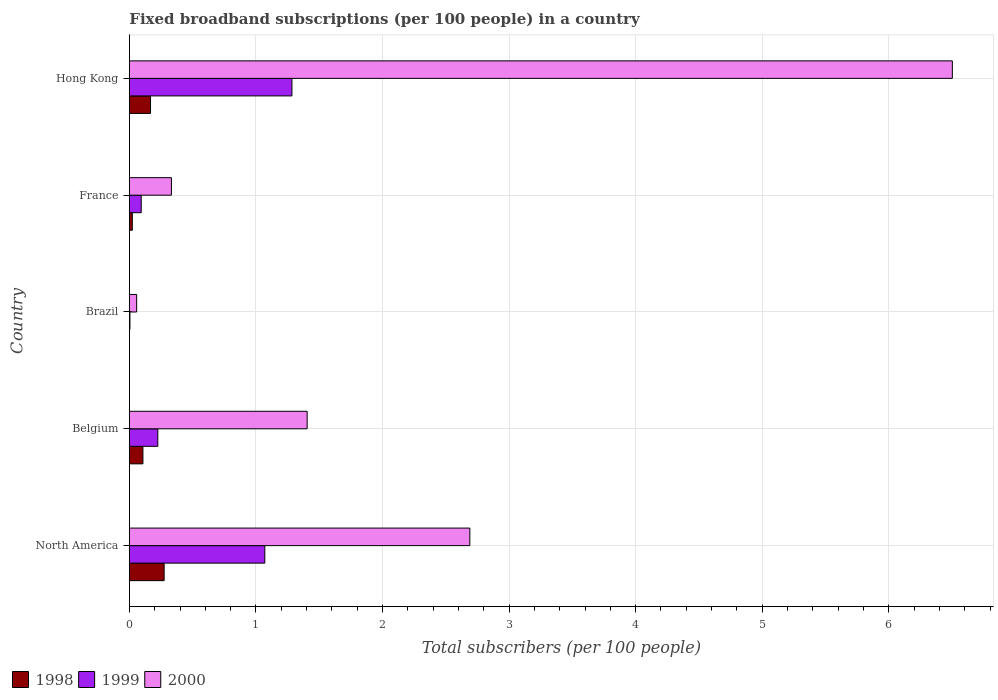How many groups of bars are there?
Offer a very short reply. 5. Are the number of bars on each tick of the Y-axis equal?
Keep it short and to the point. Yes. How many bars are there on the 4th tick from the top?
Ensure brevity in your answer.  3. What is the label of the 3rd group of bars from the top?
Ensure brevity in your answer.  Brazil. What is the number of broadband subscriptions in 1999 in Hong Kong?
Provide a succinct answer. 1.28. Across all countries, what is the maximum number of broadband subscriptions in 1998?
Ensure brevity in your answer.  0.27. Across all countries, what is the minimum number of broadband subscriptions in 1999?
Provide a succinct answer. 0. In which country was the number of broadband subscriptions in 1999 maximum?
Give a very brief answer. Hong Kong. In which country was the number of broadband subscriptions in 1998 minimum?
Ensure brevity in your answer.  Brazil. What is the total number of broadband subscriptions in 1998 in the graph?
Offer a terse response. 0.57. What is the difference between the number of broadband subscriptions in 1998 in Belgium and that in Hong Kong?
Your answer should be compact. -0.06. What is the difference between the number of broadband subscriptions in 1998 in Hong Kong and the number of broadband subscriptions in 2000 in France?
Make the answer very short. -0.17. What is the average number of broadband subscriptions in 2000 per country?
Your answer should be very brief. 2.2. What is the difference between the number of broadband subscriptions in 1999 and number of broadband subscriptions in 2000 in North America?
Give a very brief answer. -1.62. What is the ratio of the number of broadband subscriptions in 1999 in Brazil to that in North America?
Provide a succinct answer. 0. Is the number of broadband subscriptions in 1999 in Hong Kong less than that in North America?
Keep it short and to the point. No. What is the difference between the highest and the second highest number of broadband subscriptions in 1999?
Keep it short and to the point. 0.21. What is the difference between the highest and the lowest number of broadband subscriptions in 1999?
Offer a very short reply. 1.28. Is it the case that in every country, the sum of the number of broadband subscriptions in 2000 and number of broadband subscriptions in 1998 is greater than the number of broadband subscriptions in 1999?
Give a very brief answer. Yes. How many bars are there?
Your answer should be compact. 15. What is the difference between two consecutive major ticks on the X-axis?
Offer a very short reply. 1. Are the values on the major ticks of X-axis written in scientific E-notation?
Provide a short and direct response. No. Does the graph contain any zero values?
Offer a terse response. No. Does the graph contain grids?
Keep it short and to the point. Yes. Where does the legend appear in the graph?
Make the answer very short. Bottom left. How many legend labels are there?
Provide a short and direct response. 3. How are the legend labels stacked?
Give a very brief answer. Horizontal. What is the title of the graph?
Your response must be concise. Fixed broadband subscriptions (per 100 people) in a country. What is the label or title of the X-axis?
Provide a short and direct response. Total subscribers (per 100 people). What is the Total subscribers (per 100 people) in 1998 in North America?
Ensure brevity in your answer.  0.27. What is the Total subscribers (per 100 people) in 1999 in North America?
Make the answer very short. 1.07. What is the Total subscribers (per 100 people) in 2000 in North America?
Keep it short and to the point. 2.69. What is the Total subscribers (per 100 people) in 1998 in Belgium?
Offer a terse response. 0.11. What is the Total subscribers (per 100 people) in 1999 in Belgium?
Make the answer very short. 0.22. What is the Total subscribers (per 100 people) of 2000 in Belgium?
Provide a short and direct response. 1.4. What is the Total subscribers (per 100 people) in 1998 in Brazil?
Ensure brevity in your answer.  0. What is the Total subscribers (per 100 people) of 1999 in Brazil?
Your response must be concise. 0. What is the Total subscribers (per 100 people) of 2000 in Brazil?
Make the answer very short. 0.06. What is the Total subscribers (per 100 people) of 1998 in France?
Make the answer very short. 0.02. What is the Total subscribers (per 100 people) of 1999 in France?
Provide a succinct answer. 0.09. What is the Total subscribers (per 100 people) in 2000 in France?
Provide a short and direct response. 0.33. What is the Total subscribers (per 100 people) of 1998 in Hong Kong?
Make the answer very short. 0.17. What is the Total subscribers (per 100 people) of 1999 in Hong Kong?
Provide a succinct answer. 1.28. What is the Total subscribers (per 100 people) of 2000 in Hong Kong?
Your answer should be very brief. 6.5. Across all countries, what is the maximum Total subscribers (per 100 people) of 1998?
Offer a very short reply. 0.27. Across all countries, what is the maximum Total subscribers (per 100 people) of 1999?
Provide a succinct answer. 1.28. Across all countries, what is the maximum Total subscribers (per 100 people) in 2000?
Provide a succinct answer. 6.5. Across all countries, what is the minimum Total subscribers (per 100 people) of 1998?
Make the answer very short. 0. Across all countries, what is the minimum Total subscribers (per 100 people) in 1999?
Offer a very short reply. 0. Across all countries, what is the minimum Total subscribers (per 100 people) of 2000?
Your answer should be very brief. 0.06. What is the total Total subscribers (per 100 people) of 1998 in the graph?
Provide a short and direct response. 0.57. What is the total Total subscribers (per 100 people) of 1999 in the graph?
Your response must be concise. 2.68. What is the total Total subscribers (per 100 people) of 2000 in the graph?
Your answer should be compact. 10.99. What is the difference between the Total subscribers (per 100 people) in 1998 in North America and that in Belgium?
Make the answer very short. 0.17. What is the difference between the Total subscribers (per 100 people) of 1999 in North America and that in Belgium?
Your answer should be very brief. 0.85. What is the difference between the Total subscribers (per 100 people) of 2000 in North America and that in Belgium?
Make the answer very short. 1.29. What is the difference between the Total subscribers (per 100 people) in 1998 in North America and that in Brazil?
Your response must be concise. 0.27. What is the difference between the Total subscribers (per 100 people) of 1999 in North America and that in Brazil?
Offer a very short reply. 1.07. What is the difference between the Total subscribers (per 100 people) of 2000 in North America and that in Brazil?
Your answer should be very brief. 2.63. What is the difference between the Total subscribers (per 100 people) of 1998 in North America and that in France?
Your response must be concise. 0.25. What is the difference between the Total subscribers (per 100 people) in 1999 in North America and that in France?
Your answer should be compact. 0.98. What is the difference between the Total subscribers (per 100 people) in 2000 in North America and that in France?
Your response must be concise. 2.36. What is the difference between the Total subscribers (per 100 people) of 1998 in North America and that in Hong Kong?
Provide a succinct answer. 0.11. What is the difference between the Total subscribers (per 100 people) of 1999 in North America and that in Hong Kong?
Ensure brevity in your answer.  -0.21. What is the difference between the Total subscribers (per 100 people) of 2000 in North America and that in Hong Kong?
Offer a terse response. -3.81. What is the difference between the Total subscribers (per 100 people) of 1998 in Belgium and that in Brazil?
Give a very brief answer. 0.11. What is the difference between the Total subscribers (per 100 people) in 1999 in Belgium and that in Brazil?
Your answer should be very brief. 0.22. What is the difference between the Total subscribers (per 100 people) in 2000 in Belgium and that in Brazil?
Provide a short and direct response. 1.35. What is the difference between the Total subscribers (per 100 people) of 1998 in Belgium and that in France?
Offer a very short reply. 0.08. What is the difference between the Total subscribers (per 100 people) in 1999 in Belgium and that in France?
Make the answer very short. 0.13. What is the difference between the Total subscribers (per 100 people) in 2000 in Belgium and that in France?
Give a very brief answer. 1.07. What is the difference between the Total subscribers (per 100 people) in 1998 in Belgium and that in Hong Kong?
Offer a terse response. -0.06. What is the difference between the Total subscribers (per 100 people) in 1999 in Belgium and that in Hong Kong?
Make the answer very short. -1.06. What is the difference between the Total subscribers (per 100 people) of 2000 in Belgium and that in Hong Kong?
Your answer should be very brief. -5.1. What is the difference between the Total subscribers (per 100 people) in 1998 in Brazil and that in France?
Make the answer very short. -0.02. What is the difference between the Total subscribers (per 100 people) in 1999 in Brazil and that in France?
Provide a succinct answer. -0.09. What is the difference between the Total subscribers (per 100 people) in 2000 in Brazil and that in France?
Offer a very short reply. -0.27. What is the difference between the Total subscribers (per 100 people) of 1998 in Brazil and that in Hong Kong?
Make the answer very short. -0.17. What is the difference between the Total subscribers (per 100 people) in 1999 in Brazil and that in Hong Kong?
Provide a short and direct response. -1.28. What is the difference between the Total subscribers (per 100 people) in 2000 in Brazil and that in Hong Kong?
Offer a very short reply. -6.45. What is the difference between the Total subscribers (per 100 people) in 1998 in France and that in Hong Kong?
Your answer should be very brief. -0.14. What is the difference between the Total subscribers (per 100 people) in 1999 in France and that in Hong Kong?
Ensure brevity in your answer.  -1.19. What is the difference between the Total subscribers (per 100 people) of 2000 in France and that in Hong Kong?
Provide a succinct answer. -6.17. What is the difference between the Total subscribers (per 100 people) of 1998 in North America and the Total subscribers (per 100 people) of 1999 in Belgium?
Offer a very short reply. 0.05. What is the difference between the Total subscribers (per 100 people) in 1998 in North America and the Total subscribers (per 100 people) in 2000 in Belgium?
Keep it short and to the point. -1.13. What is the difference between the Total subscribers (per 100 people) in 1999 in North America and the Total subscribers (per 100 people) in 2000 in Belgium?
Your answer should be very brief. -0.33. What is the difference between the Total subscribers (per 100 people) of 1998 in North America and the Total subscribers (per 100 people) of 1999 in Brazil?
Ensure brevity in your answer.  0.27. What is the difference between the Total subscribers (per 100 people) in 1998 in North America and the Total subscribers (per 100 people) in 2000 in Brazil?
Keep it short and to the point. 0.22. What is the difference between the Total subscribers (per 100 people) in 1999 in North America and the Total subscribers (per 100 people) in 2000 in Brazil?
Your answer should be compact. 1.01. What is the difference between the Total subscribers (per 100 people) of 1998 in North America and the Total subscribers (per 100 people) of 1999 in France?
Provide a succinct answer. 0.18. What is the difference between the Total subscribers (per 100 people) in 1998 in North America and the Total subscribers (per 100 people) in 2000 in France?
Keep it short and to the point. -0.06. What is the difference between the Total subscribers (per 100 people) of 1999 in North America and the Total subscribers (per 100 people) of 2000 in France?
Ensure brevity in your answer.  0.74. What is the difference between the Total subscribers (per 100 people) in 1998 in North America and the Total subscribers (per 100 people) in 1999 in Hong Kong?
Make the answer very short. -1.01. What is the difference between the Total subscribers (per 100 people) of 1998 in North America and the Total subscribers (per 100 people) of 2000 in Hong Kong?
Your answer should be very brief. -6.23. What is the difference between the Total subscribers (per 100 people) in 1999 in North America and the Total subscribers (per 100 people) in 2000 in Hong Kong?
Keep it short and to the point. -5.43. What is the difference between the Total subscribers (per 100 people) in 1998 in Belgium and the Total subscribers (per 100 people) in 1999 in Brazil?
Keep it short and to the point. 0.1. What is the difference between the Total subscribers (per 100 people) of 1998 in Belgium and the Total subscribers (per 100 people) of 2000 in Brazil?
Make the answer very short. 0.05. What is the difference between the Total subscribers (per 100 people) in 1999 in Belgium and the Total subscribers (per 100 people) in 2000 in Brazil?
Keep it short and to the point. 0.17. What is the difference between the Total subscribers (per 100 people) in 1998 in Belgium and the Total subscribers (per 100 people) in 1999 in France?
Offer a terse response. 0.01. What is the difference between the Total subscribers (per 100 people) in 1998 in Belgium and the Total subscribers (per 100 people) in 2000 in France?
Offer a terse response. -0.23. What is the difference between the Total subscribers (per 100 people) in 1999 in Belgium and the Total subscribers (per 100 people) in 2000 in France?
Keep it short and to the point. -0.11. What is the difference between the Total subscribers (per 100 people) of 1998 in Belgium and the Total subscribers (per 100 people) of 1999 in Hong Kong?
Keep it short and to the point. -1.18. What is the difference between the Total subscribers (per 100 people) of 1998 in Belgium and the Total subscribers (per 100 people) of 2000 in Hong Kong?
Your response must be concise. -6.4. What is the difference between the Total subscribers (per 100 people) of 1999 in Belgium and the Total subscribers (per 100 people) of 2000 in Hong Kong?
Offer a very short reply. -6.28. What is the difference between the Total subscribers (per 100 people) in 1998 in Brazil and the Total subscribers (per 100 people) in 1999 in France?
Offer a very short reply. -0.09. What is the difference between the Total subscribers (per 100 people) in 1998 in Brazil and the Total subscribers (per 100 people) in 2000 in France?
Give a very brief answer. -0.33. What is the difference between the Total subscribers (per 100 people) of 1999 in Brazil and the Total subscribers (per 100 people) of 2000 in France?
Make the answer very short. -0.33. What is the difference between the Total subscribers (per 100 people) in 1998 in Brazil and the Total subscribers (per 100 people) in 1999 in Hong Kong?
Offer a very short reply. -1.28. What is the difference between the Total subscribers (per 100 people) in 1998 in Brazil and the Total subscribers (per 100 people) in 2000 in Hong Kong?
Provide a succinct answer. -6.5. What is the difference between the Total subscribers (per 100 people) in 1999 in Brazil and the Total subscribers (per 100 people) in 2000 in Hong Kong?
Your answer should be compact. -6.5. What is the difference between the Total subscribers (per 100 people) of 1998 in France and the Total subscribers (per 100 people) of 1999 in Hong Kong?
Ensure brevity in your answer.  -1.26. What is the difference between the Total subscribers (per 100 people) of 1998 in France and the Total subscribers (per 100 people) of 2000 in Hong Kong?
Keep it short and to the point. -6.48. What is the difference between the Total subscribers (per 100 people) of 1999 in France and the Total subscribers (per 100 people) of 2000 in Hong Kong?
Offer a terse response. -6.41. What is the average Total subscribers (per 100 people) of 1998 per country?
Your answer should be very brief. 0.11. What is the average Total subscribers (per 100 people) in 1999 per country?
Ensure brevity in your answer.  0.54. What is the average Total subscribers (per 100 people) in 2000 per country?
Your answer should be compact. 2.2. What is the difference between the Total subscribers (per 100 people) of 1998 and Total subscribers (per 100 people) of 1999 in North America?
Offer a terse response. -0.8. What is the difference between the Total subscribers (per 100 people) in 1998 and Total subscribers (per 100 people) in 2000 in North America?
Your answer should be very brief. -2.42. What is the difference between the Total subscribers (per 100 people) of 1999 and Total subscribers (per 100 people) of 2000 in North America?
Provide a succinct answer. -1.62. What is the difference between the Total subscribers (per 100 people) of 1998 and Total subscribers (per 100 people) of 1999 in Belgium?
Make the answer very short. -0.12. What is the difference between the Total subscribers (per 100 people) of 1998 and Total subscribers (per 100 people) of 2000 in Belgium?
Provide a short and direct response. -1.3. What is the difference between the Total subscribers (per 100 people) of 1999 and Total subscribers (per 100 people) of 2000 in Belgium?
Your answer should be compact. -1.18. What is the difference between the Total subscribers (per 100 people) of 1998 and Total subscribers (per 100 people) of 1999 in Brazil?
Offer a very short reply. -0. What is the difference between the Total subscribers (per 100 people) of 1998 and Total subscribers (per 100 people) of 2000 in Brazil?
Your answer should be compact. -0.06. What is the difference between the Total subscribers (per 100 people) of 1999 and Total subscribers (per 100 people) of 2000 in Brazil?
Keep it short and to the point. -0.05. What is the difference between the Total subscribers (per 100 people) in 1998 and Total subscribers (per 100 people) in 1999 in France?
Provide a succinct answer. -0.07. What is the difference between the Total subscribers (per 100 people) of 1998 and Total subscribers (per 100 people) of 2000 in France?
Ensure brevity in your answer.  -0.31. What is the difference between the Total subscribers (per 100 people) in 1999 and Total subscribers (per 100 people) in 2000 in France?
Offer a terse response. -0.24. What is the difference between the Total subscribers (per 100 people) of 1998 and Total subscribers (per 100 people) of 1999 in Hong Kong?
Ensure brevity in your answer.  -1.12. What is the difference between the Total subscribers (per 100 people) in 1998 and Total subscribers (per 100 people) in 2000 in Hong Kong?
Make the answer very short. -6.34. What is the difference between the Total subscribers (per 100 people) of 1999 and Total subscribers (per 100 people) of 2000 in Hong Kong?
Keep it short and to the point. -5.22. What is the ratio of the Total subscribers (per 100 people) in 1998 in North America to that in Belgium?
Your answer should be very brief. 2.57. What is the ratio of the Total subscribers (per 100 people) of 1999 in North America to that in Belgium?
Offer a very short reply. 4.76. What is the ratio of the Total subscribers (per 100 people) in 2000 in North America to that in Belgium?
Make the answer very short. 1.92. What is the ratio of the Total subscribers (per 100 people) of 1998 in North America to that in Brazil?
Offer a terse response. 465.15. What is the ratio of the Total subscribers (per 100 people) in 1999 in North America to that in Brazil?
Offer a very short reply. 262.9. What is the ratio of the Total subscribers (per 100 people) of 2000 in North America to that in Brazil?
Provide a succinct answer. 46.94. What is the ratio of the Total subscribers (per 100 people) in 1998 in North America to that in France?
Give a very brief answer. 11.95. What is the ratio of the Total subscribers (per 100 people) in 1999 in North America to that in France?
Offer a very short reply. 11.46. What is the ratio of the Total subscribers (per 100 people) in 2000 in North America to that in France?
Offer a terse response. 8.1. What is the ratio of the Total subscribers (per 100 people) in 1998 in North America to that in Hong Kong?
Provide a succinct answer. 1.64. What is the ratio of the Total subscribers (per 100 people) in 1999 in North America to that in Hong Kong?
Your answer should be very brief. 0.83. What is the ratio of the Total subscribers (per 100 people) of 2000 in North America to that in Hong Kong?
Ensure brevity in your answer.  0.41. What is the ratio of the Total subscribers (per 100 people) of 1998 in Belgium to that in Brazil?
Keep it short and to the point. 181.1. What is the ratio of the Total subscribers (per 100 people) of 1999 in Belgium to that in Brazil?
Your answer should be very brief. 55.18. What is the ratio of the Total subscribers (per 100 people) in 2000 in Belgium to that in Brazil?
Ensure brevity in your answer.  24.51. What is the ratio of the Total subscribers (per 100 people) of 1998 in Belgium to that in France?
Provide a short and direct response. 4.65. What is the ratio of the Total subscribers (per 100 people) in 1999 in Belgium to that in France?
Ensure brevity in your answer.  2.4. What is the ratio of the Total subscribers (per 100 people) of 2000 in Belgium to that in France?
Keep it short and to the point. 4.23. What is the ratio of the Total subscribers (per 100 people) of 1998 in Belgium to that in Hong Kong?
Ensure brevity in your answer.  0.64. What is the ratio of the Total subscribers (per 100 people) in 1999 in Belgium to that in Hong Kong?
Provide a short and direct response. 0.17. What is the ratio of the Total subscribers (per 100 people) in 2000 in Belgium to that in Hong Kong?
Your answer should be compact. 0.22. What is the ratio of the Total subscribers (per 100 people) of 1998 in Brazil to that in France?
Provide a succinct answer. 0.03. What is the ratio of the Total subscribers (per 100 people) in 1999 in Brazil to that in France?
Your answer should be compact. 0.04. What is the ratio of the Total subscribers (per 100 people) in 2000 in Brazil to that in France?
Provide a short and direct response. 0.17. What is the ratio of the Total subscribers (per 100 people) of 1998 in Brazil to that in Hong Kong?
Offer a terse response. 0. What is the ratio of the Total subscribers (per 100 people) in 1999 in Brazil to that in Hong Kong?
Offer a terse response. 0. What is the ratio of the Total subscribers (per 100 people) in 2000 in Brazil to that in Hong Kong?
Offer a very short reply. 0.01. What is the ratio of the Total subscribers (per 100 people) in 1998 in France to that in Hong Kong?
Offer a very short reply. 0.14. What is the ratio of the Total subscribers (per 100 people) in 1999 in France to that in Hong Kong?
Give a very brief answer. 0.07. What is the ratio of the Total subscribers (per 100 people) of 2000 in France to that in Hong Kong?
Your answer should be compact. 0.05. What is the difference between the highest and the second highest Total subscribers (per 100 people) in 1998?
Provide a short and direct response. 0.11. What is the difference between the highest and the second highest Total subscribers (per 100 people) of 1999?
Give a very brief answer. 0.21. What is the difference between the highest and the second highest Total subscribers (per 100 people) of 2000?
Keep it short and to the point. 3.81. What is the difference between the highest and the lowest Total subscribers (per 100 people) of 1998?
Provide a short and direct response. 0.27. What is the difference between the highest and the lowest Total subscribers (per 100 people) in 1999?
Offer a very short reply. 1.28. What is the difference between the highest and the lowest Total subscribers (per 100 people) in 2000?
Your answer should be very brief. 6.45. 